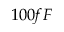Convert formula to latex. <formula><loc_0><loc_0><loc_500><loc_500>1 0 0 f F</formula> 